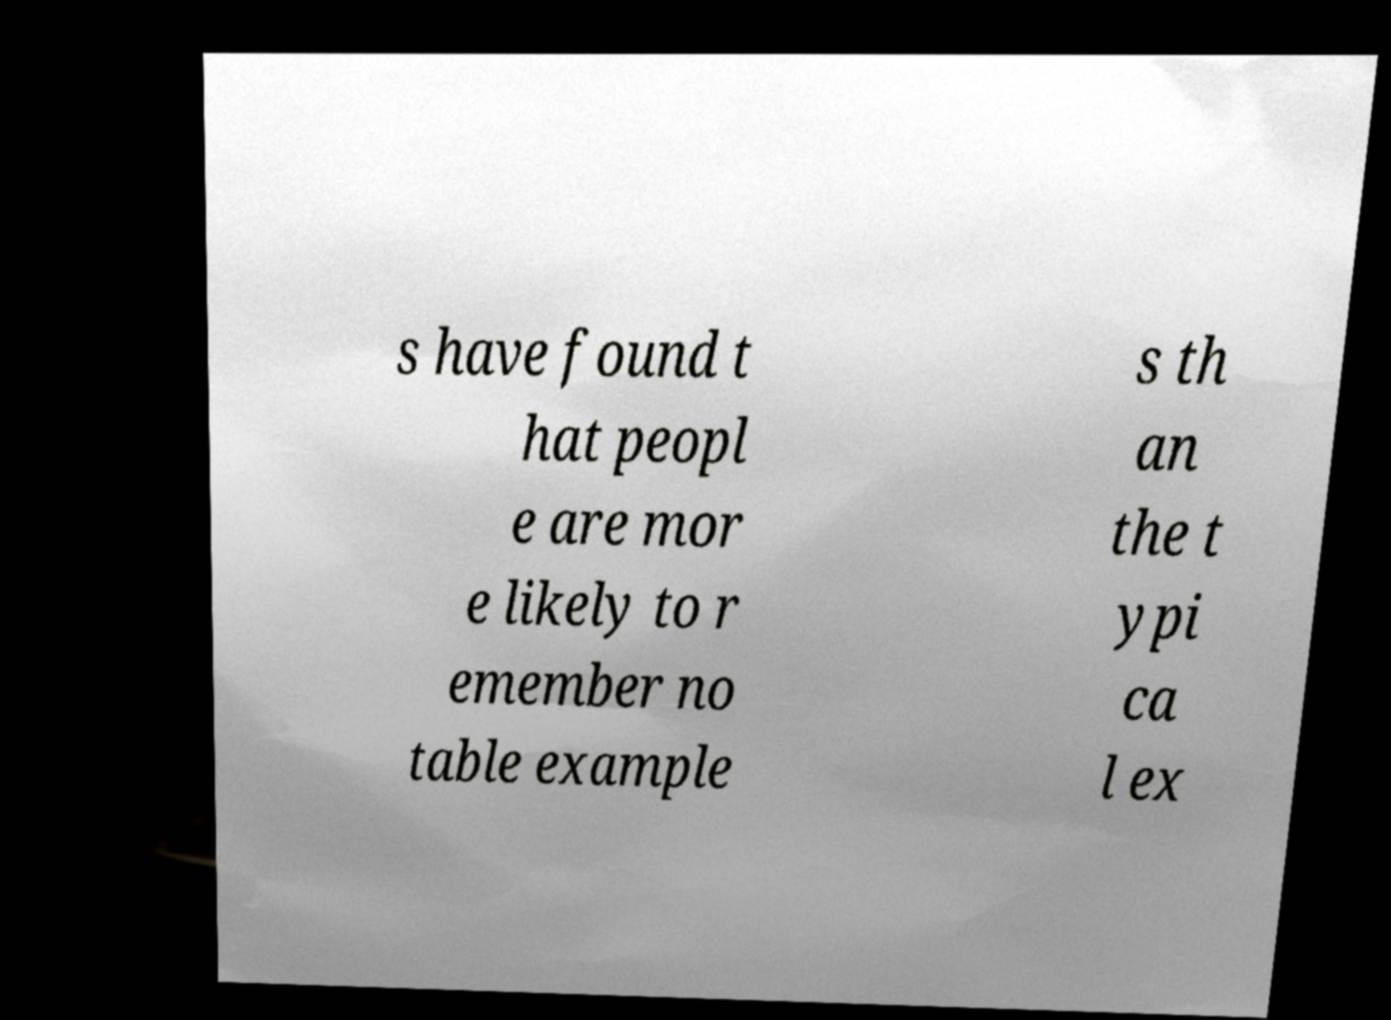For documentation purposes, I need the text within this image transcribed. Could you provide that? s have found t hat peopl e are mor e likely to r emember no table example s th an the t ypi ca l ex 